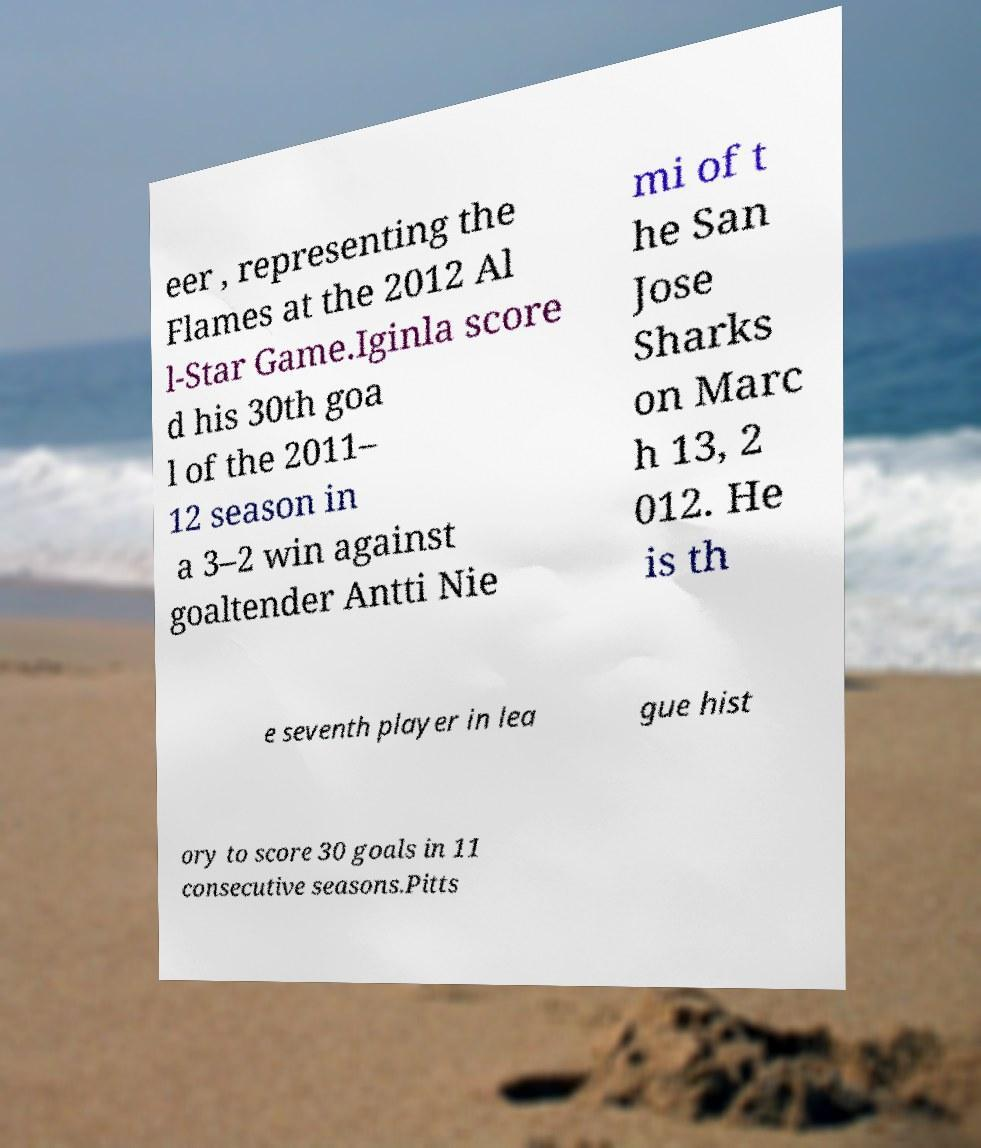Can you accurately transcribe the text from the provided image for me? eer , representing the Flames at the 2012 Al l-Star Game.Iginla score d his 30th goa l of the 2011– 12 season in a 3–2 win against goaltender Antti Nie mi of t he San Jose Sharks on Marc h 13, 2 012. He is th e seventh player in lea gue hist ory to score 30 goals in 11 consecutive seasons.Pitts 